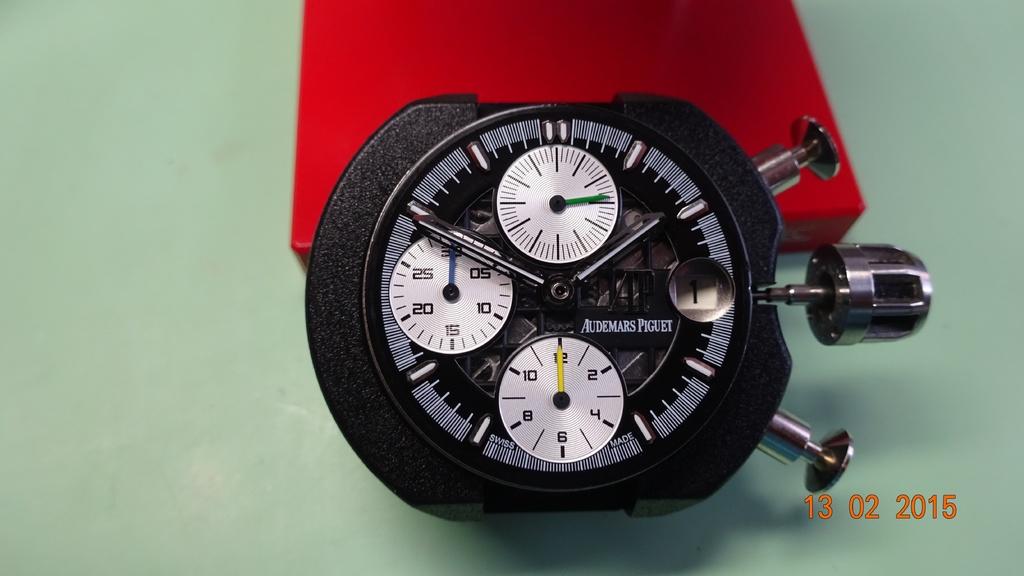What´s the brand of the clock?
Your answer should be very brief. Audemars piguet. What date was this picture taken?
Give a very brief answer. 13 02 2015. 